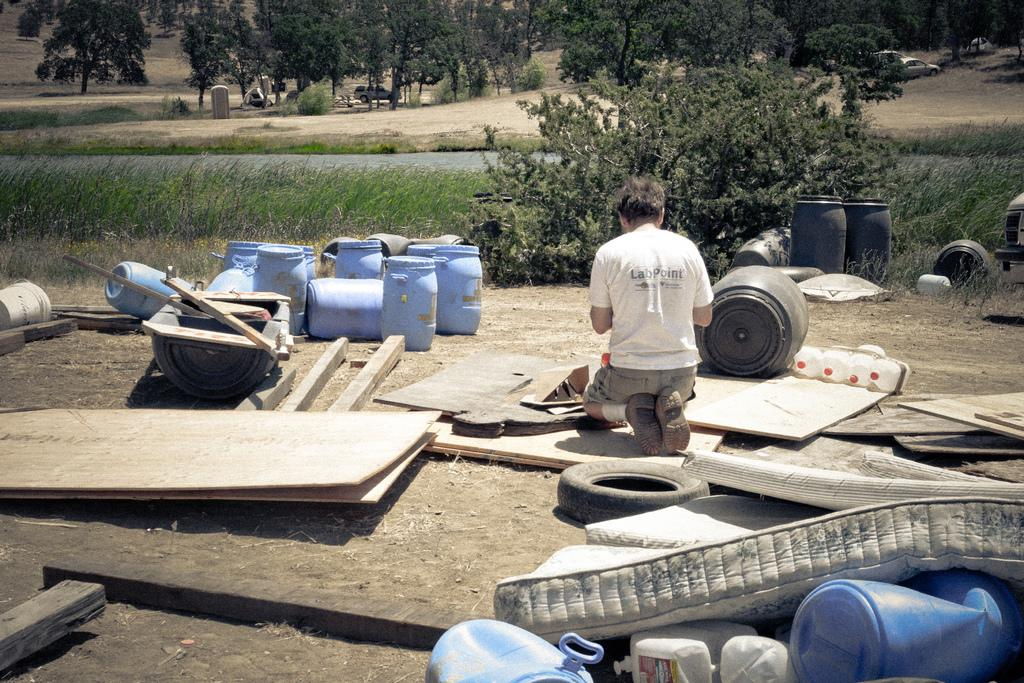Who is present in the image? There is a man in the image. What is the man wearing? The man is wearing a white t-shirt. What can be seen on the left side of the image? There are plastic drums in blue color on the left side of the image. What type of natural scenery is visible in the image? There are trees visible at the back side of the image. What type of writing can be seen on the man's t-shirt in the image? There is no writing visible on the man's t-shirt in the image. How many frogs are present in the image? There are no frogs present in the image. 